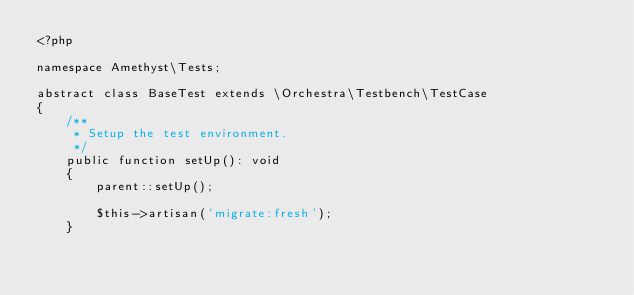<code> <loc_0><loc_0><loc_500><loc_500><_PHP_><?php

namespace Amethyst\Tests;

abstract class BaseTest extends \Orchestra\Testbench\TestCase
{
    /**
     * Setup the test environment.
     */
    public function setUp(): void
    {
        parent::setUp();

        $this->artisan('migrate:fresh');
    }
</code> 